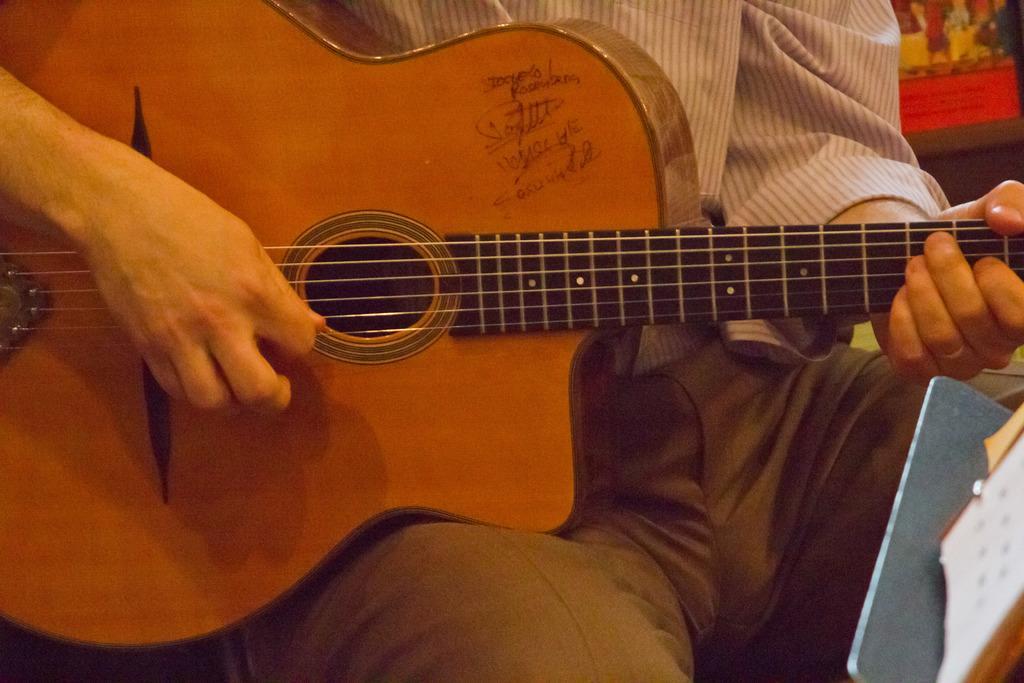Could you give a brief overview of what you see in this image? This picture seems to be of inside. In the center there is a man wearing white color shirt, sitting and playing guitar. On the left there is a stand. 